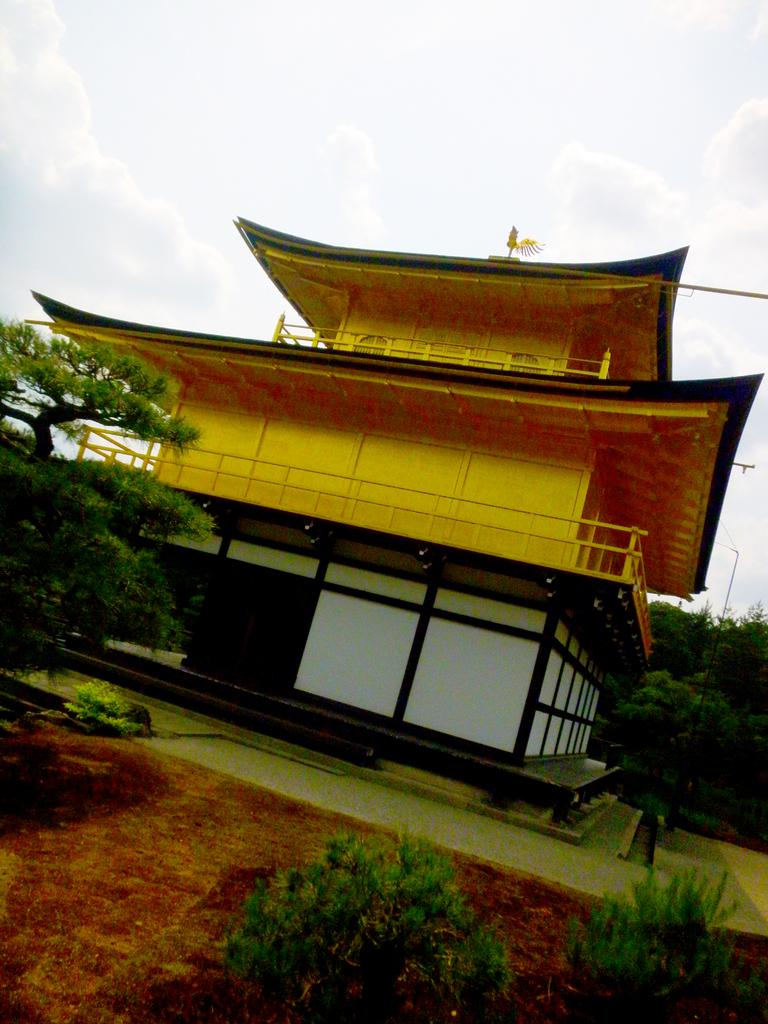What type of natural elements can be seen in the image? There are trees and plants in the image. What structure is located in the middle of the image? There is a building in the middle of the image. What is visible at the top of the image? The sky is visible at the top of the image. Where is the giraffe standing in the image? There is no giraffe present in the image. What type of furniture can be seen in the image? There is no furniture, such as a desk, present in the image. 